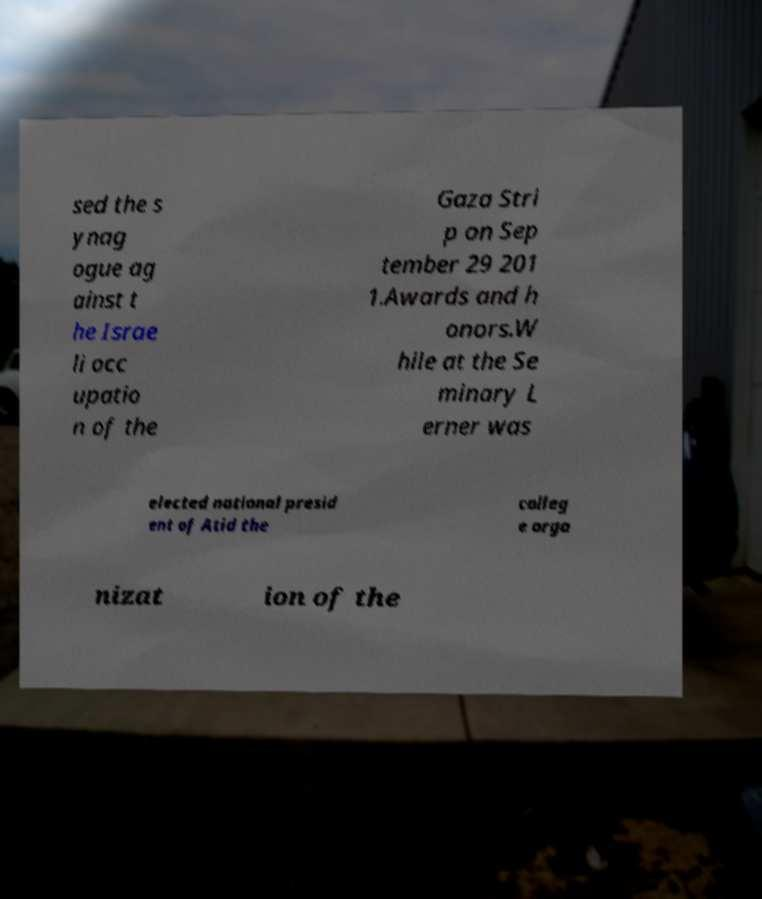There's text embedded in this image that I need extracted. Can you transcribe it verbatim? sed the s ynag ogue ag ainst t he Israe li occ upatio n of the Gaza Stri p on Sep tember 29 201 1.Awards and h onors.W hile at the Se minary L erner was elected national presid ent of Atid the colleg e orga nizat ion of the 